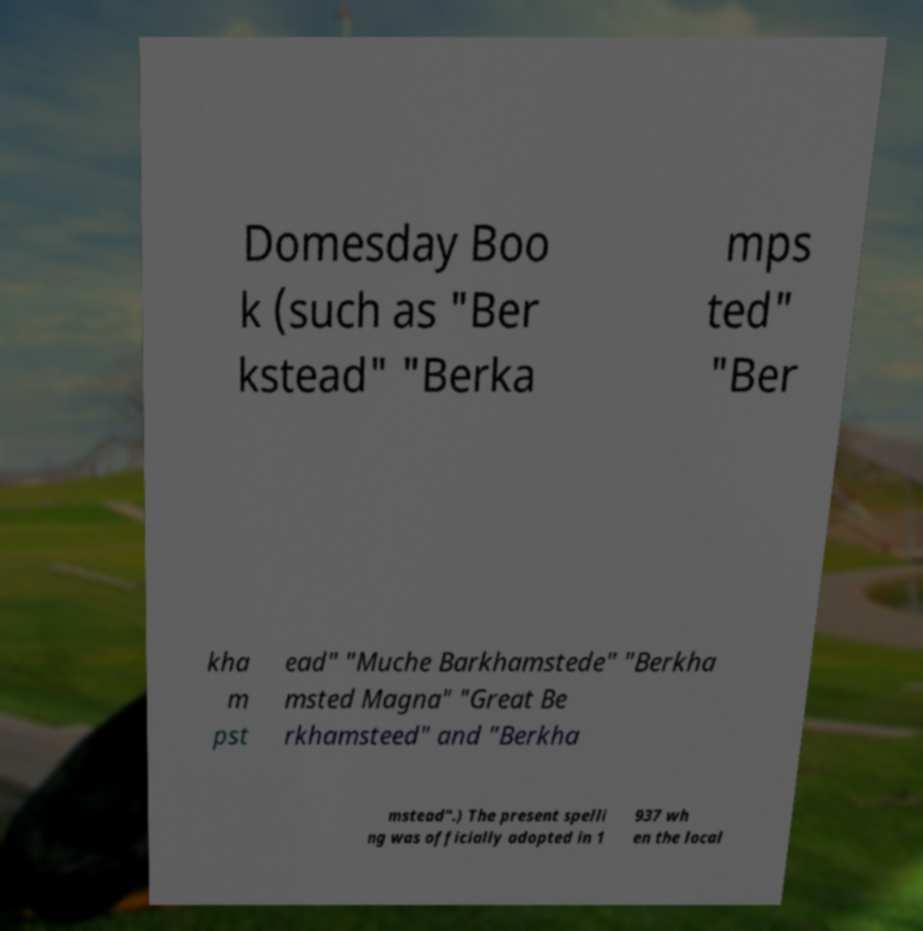For documentation purposes, I need the text within this image transcribed. Could you provide that? Domesday Boo k (such as "Ber kstead" "Berka mps ted" "Ber kha m pst ead" "Muche Barkhamstede" "Berkha msted Magna" "Great Be rkhamsteed" and "Berkha mstead".) The present spelli ng was officially adopted in 1 937 wh en the local 